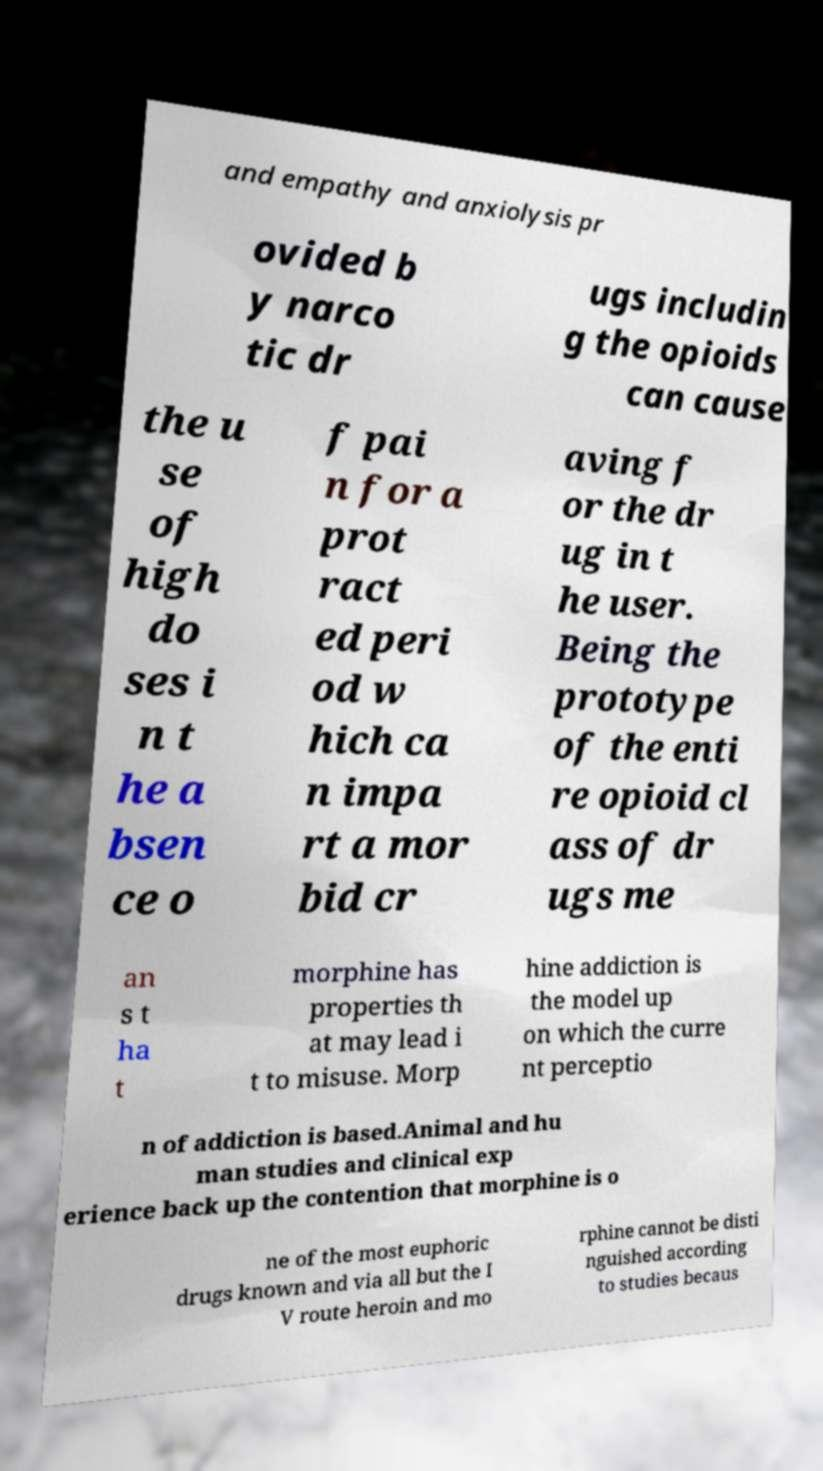Please read and relay the text visible in this image. What does it say? and empathy and anxiolysis pr ovided b y narco tic dr ugs includin g the opioids can cause the u se of high do ses i n t he a bsen ce o f pai n for a prot ract ed peri od w hich ca n impa rt a mor bid cr aving f or the dr ug in t he user. Being the prototype of the enti re opioid cl ass of dr ugs me an s t ha t morphine has properties th at may lead i t to misuse. Morp hine addiction is the model up on which the curre nt perceptio n of addiction is based.Animal and hu man studies and clinical exp erience back up the contention that morphine is o ne of the most euphoric drugs known and via all but the I V route heroin and mo rphine cannot be disti nguished according to studies becaus 